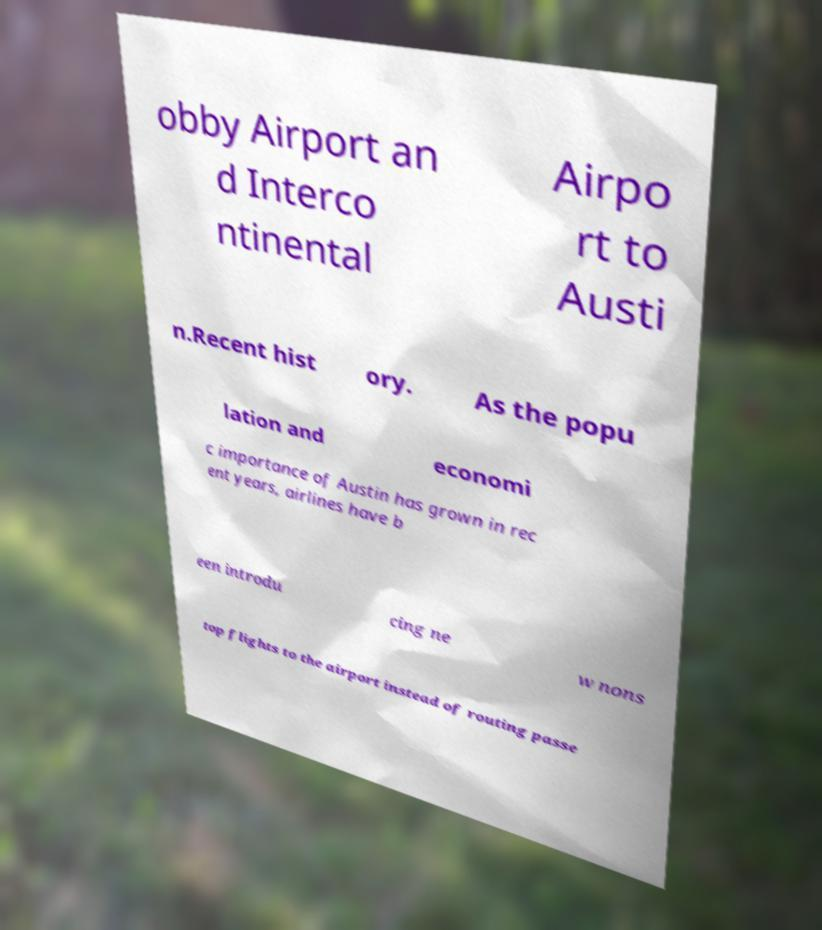For documentation purposes, I need the text within this image transcribed. Could you provide that? obby Airport an d Interco ntinental Airpo rt to Austi n.Recent hist ory. As the popu lation and economi c importance of Austin has grown in rec ent years, airlines have b een introdu cing ne w nons top flights to the airport instead of routing passe 